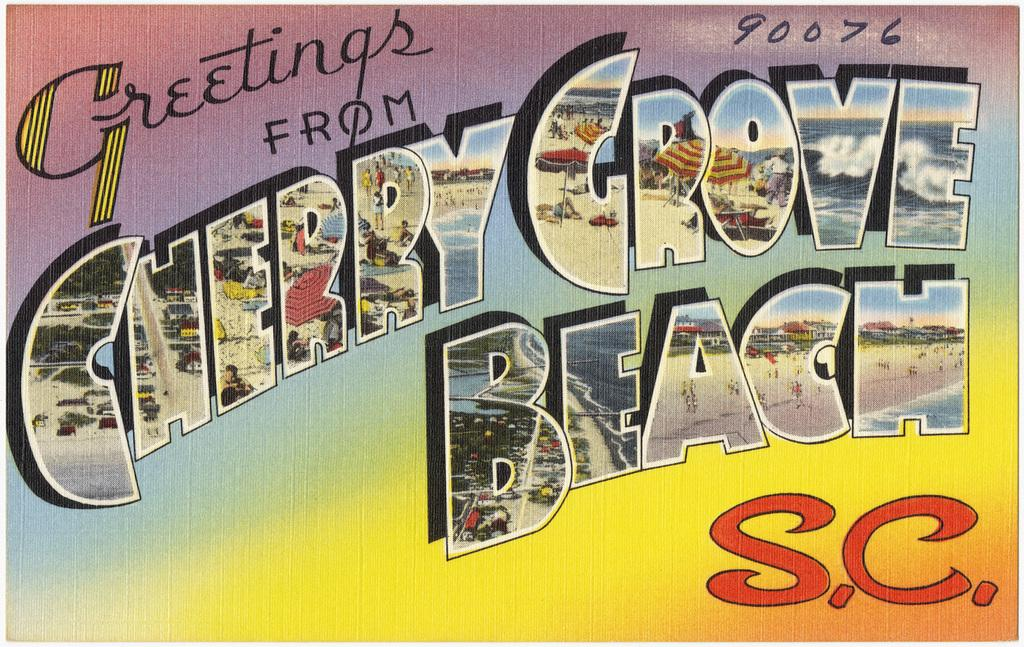<image>
Give a short and clear explanation of the subsequent image. A postcard reading Greetings from Cherry Grove Beach S.C. 